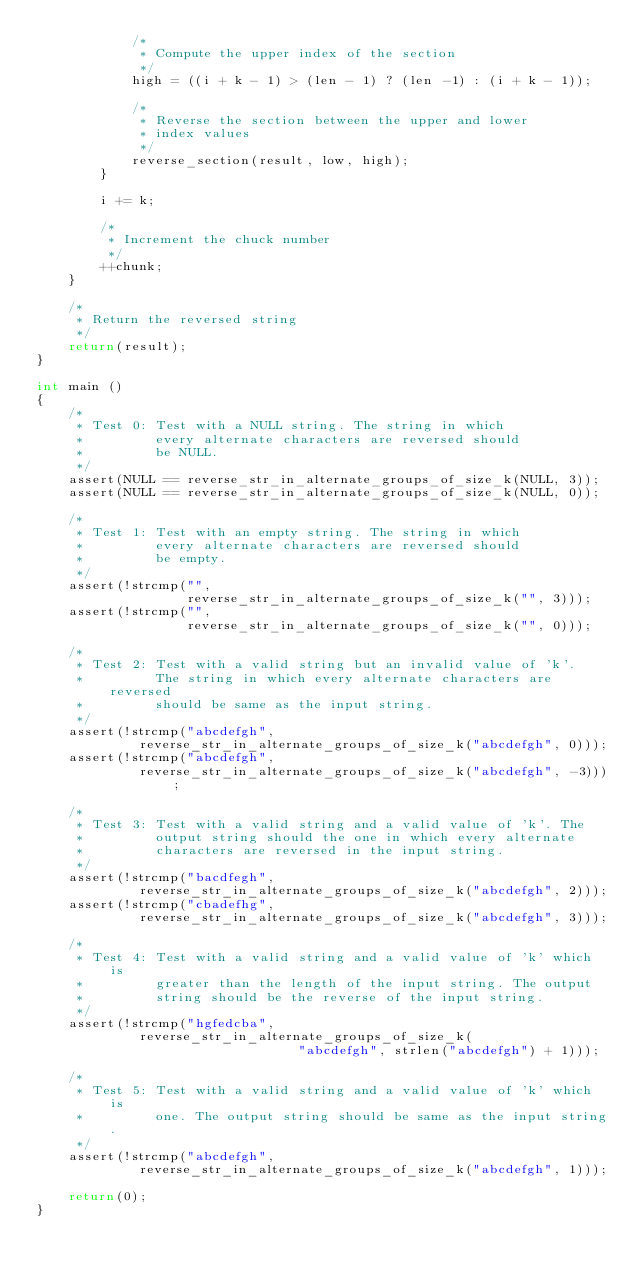<code> <loc_0><loc_0><loc_500><loc_500><_C_>            /*
             * Compute the upper index of the section
             */
            high = ((i + k - 1) > (len - 1) ? (len -1) : (i + k - 1));

            /*
             * Reverse the section between the upper and lower
             * index values
             */
            reverse_section(result, low, high);
        }

        i += k;

        /*
         * Increment the chuck number
         */
        ++chunk;
    }

    /*
     * Return the reversed string
     */
    return(result);
}

int main ()
{
    /*
     * Test 0: Test with a NULL string. The string in which
     *         every alternate characters are reversed should
     *         be NULL.
     */
    assert(NULL == reverse_str_in_alternate_groups_of_size_k(NULL, 3));
    assert(NULL == reverse_str_in_alternate_groups_of_size_k(NULL, 0));

    /*
     * Test 1: Test with an empty string. The string in which
     *         every alternate characters are reversed should
     *         be empty.
     */
    assert(!strcmp("",
                   reverse_str_in_alternate_groups_of_size_k("", 3)));
    assert(!strcmp("",
                   reverse_str_in_alternate_groups_of_size_k("", 0)));

    /*
     * Test 2: Test with a valid string but an invalid value of 'k'.
     *         The string in which every alternate characters are reversed
     *         should be same as the input string.
     */
    assert(!strcmp("abcdefgh",
             reverse_str_in_alternate_groups_of_size_k("abcdefgh", 0)));
    assert(!strcmp("abcdefgh",
             reverse_str_in_alternate_groups_of_size_k("abcdefgh", -3)));

    /*
     * Test 3: Test with a valid string and a valid value of 'k'. The
     *         output string should the one in which every alternate
     *         characters are reversed in the input string.
     */
    assert(!strcmp("bacdfegh",
             reverse_str_in_alternate_groups_of_size_k("abcdefgh", 2)));
    assert(!strcmp("cbadefhg",
             reverse_str_in_alternate_groups_of_size_k("abcdefgh", 3)));

    /*
     * Test 4: Test with a valid string and a valid value of 'k' which is
     *         greater than the length of the input string. The output
     *         string should be the reverse of the input string.
     */
    assert(!strcmp("hgfedcba",
             reverse_str_in_alternate_groups_of_size_k(
                                 "abcdefgh", strlen("abcdefgh") + 1)));

    /*
     * Test 5: Test with a valid string and a valid value of 'k' which is
     *         one. The output string should be same as the input string.
     */
    assert(!strcmp("abcdefgh",
             reverse_str_in_alternate_groups_of_size_k("abcdefgh", 1)));

    return(0);
}
</code> 